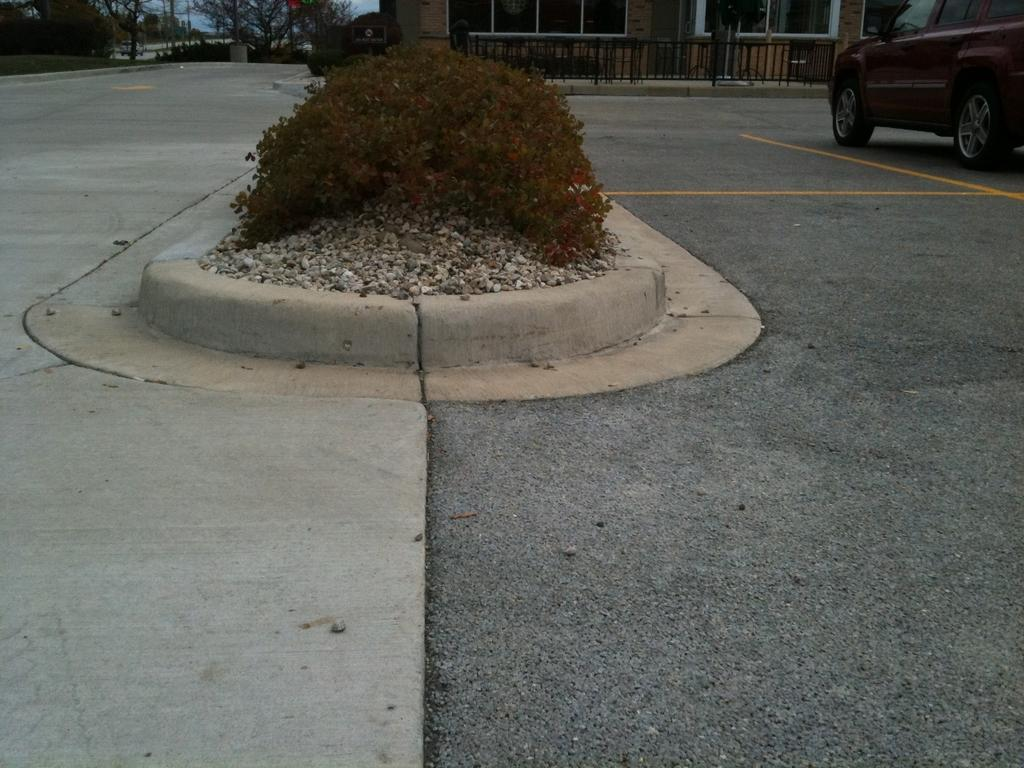What is at the bottom of the image? There is a road at the bottom of the image. What can be seen on the right side of the image? There is a car on the right side of the image. What is visible in the background of the image? There is a building and trees in the background of the image. Can you describe any other vegetation in the image? There is a shrub visible in the image. What type of needle is being used to sew the flag in the image? There is no flag or needle present in the image. What is the source of pleasure for the people in the image? There are no people or pleasure-related activities depicted in the image. 